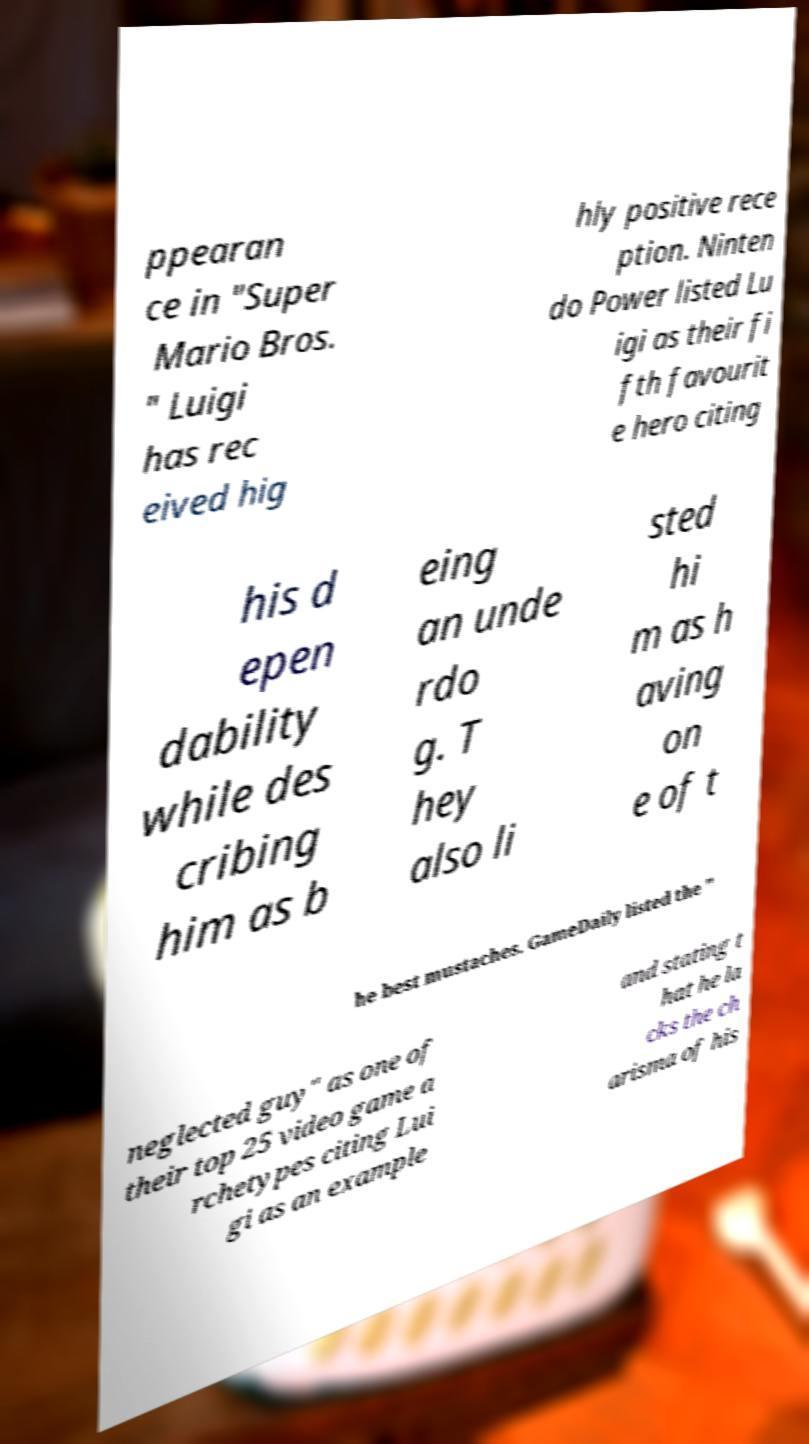What messages or text are displayed in this image? I need them in a readable, typed format. ppearan ce in "Super Mario Bros. " Luigi has rec eived hig hly positive rece ption. Ninten do Power listed Lu igi as their fi fth favourit e hero citing his d epen dability while des cribing him as b eing an unde rdo g. T hey also li sted hi m as h aving on e of t he best mustaches. GameDaily listed the " neglected guy" as one of their top 25 video game a rchetypes citing Lui gi as an example and stating t hat he la cks the ch arisma of his 